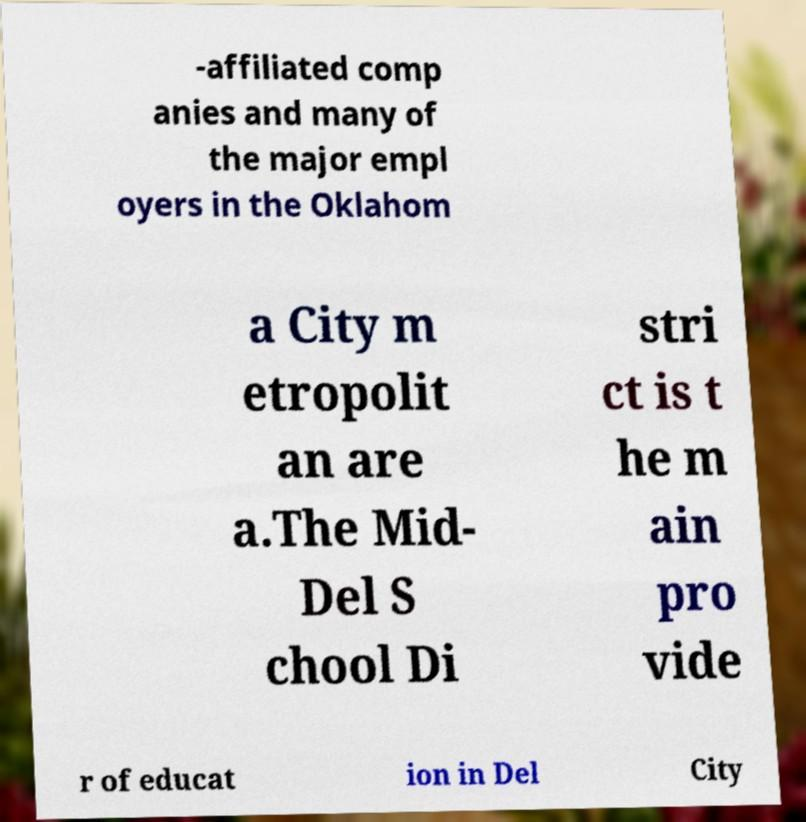Can you accurately transcribe the text from the provided image for me? -affiliated comp anies and many of the major empl oyers in the Oklahom a City m etropolit an are a.The Mid- Del S chool Di stri ct is t he m ain pro vide r of educat ion in Del City 